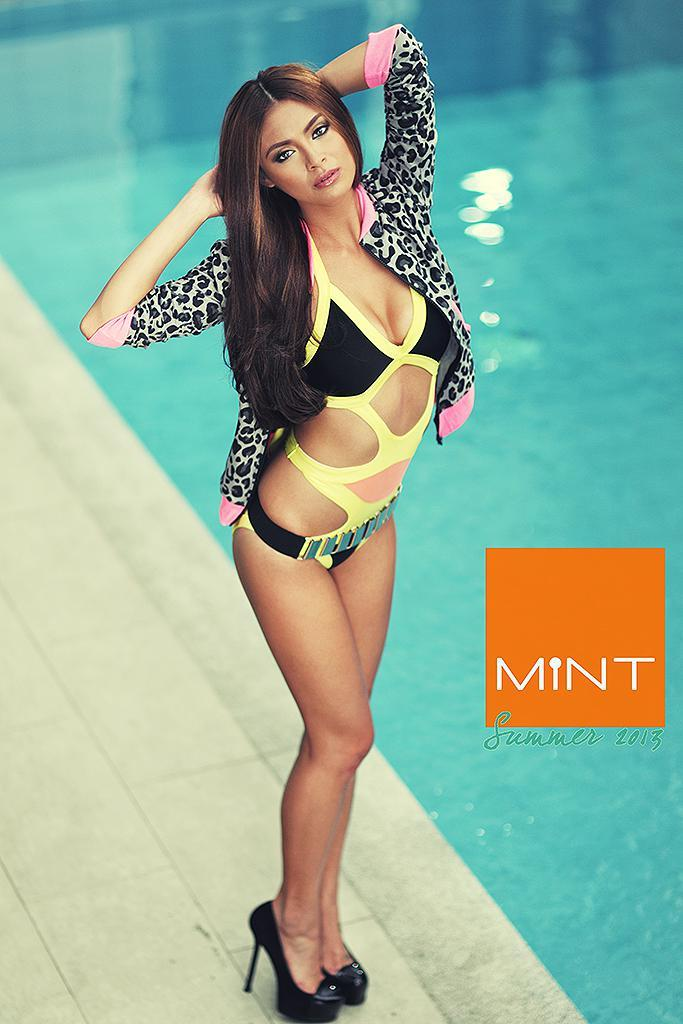Who is present in the image? There is a woman in the image. What is the woman's location in relation to the swimming pool? The woman is standing near a swimming pool. What type of magic is the woman performing near the chair in the image? There is no chair or magic present in the image; it only features a woman standing near a swimming pool. 